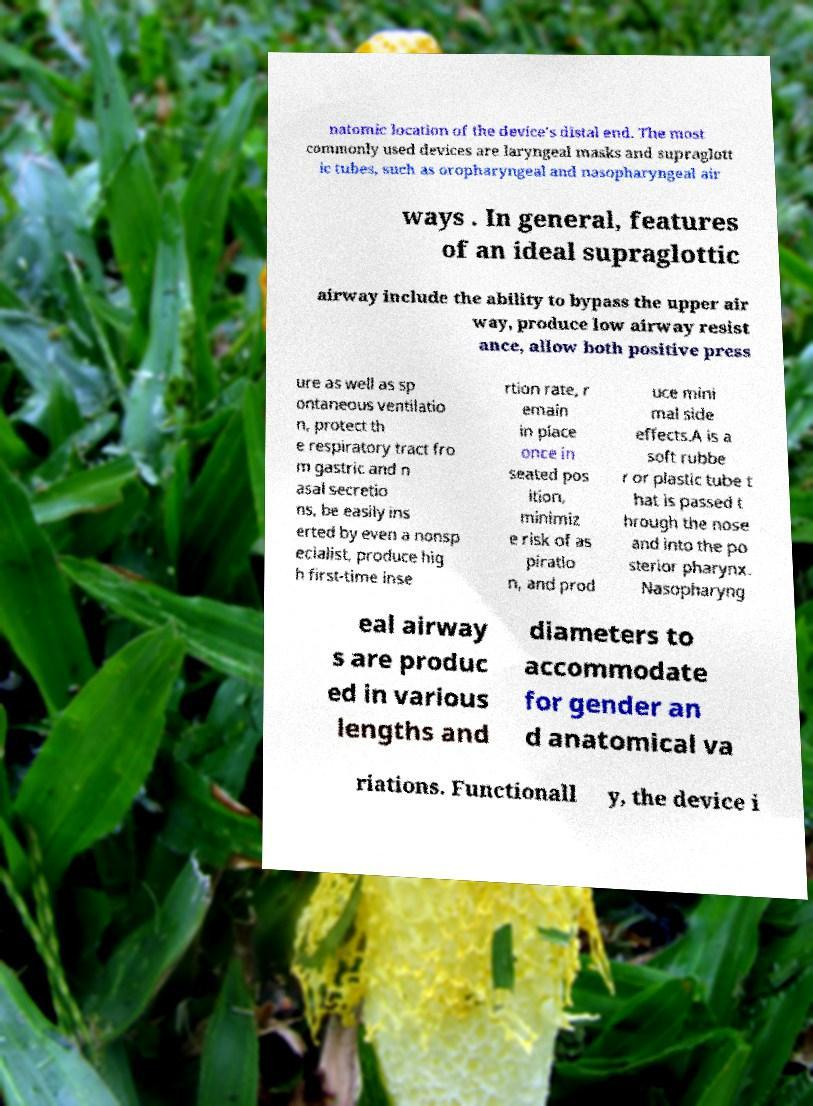Could you extract and type out the text from this image? natomic location of the device's distal end. The most commonly used devices are laryngeal masks and supraglott ic tubes, such as oropharyngeal and nasopharyngeal air ways . In general, features of an ideal supraglottic airway include the ability to bypass the upper air way, produce low airway resist ance, allow both positive press ure as well as sp ontaneous ventilatio n, protect th e respiratory tract fro m gastric and n asal secretio ns, be easily ins erted by even a nonsp ecialist, produce hig h first-time inse rtion rate, r emain in place once in seated pos ition, minimiz e risk of as piratio n, and prod uce mini mal side effects.A is a soft rubbe r or plastic tube t hat is passed t hrough the nose and into the po sterior pharynx. Nasopharyng eal airway s are produc ed in various lengths and diameters to accommodate for gender an d anatomical va riations. Functionall y, the device i 